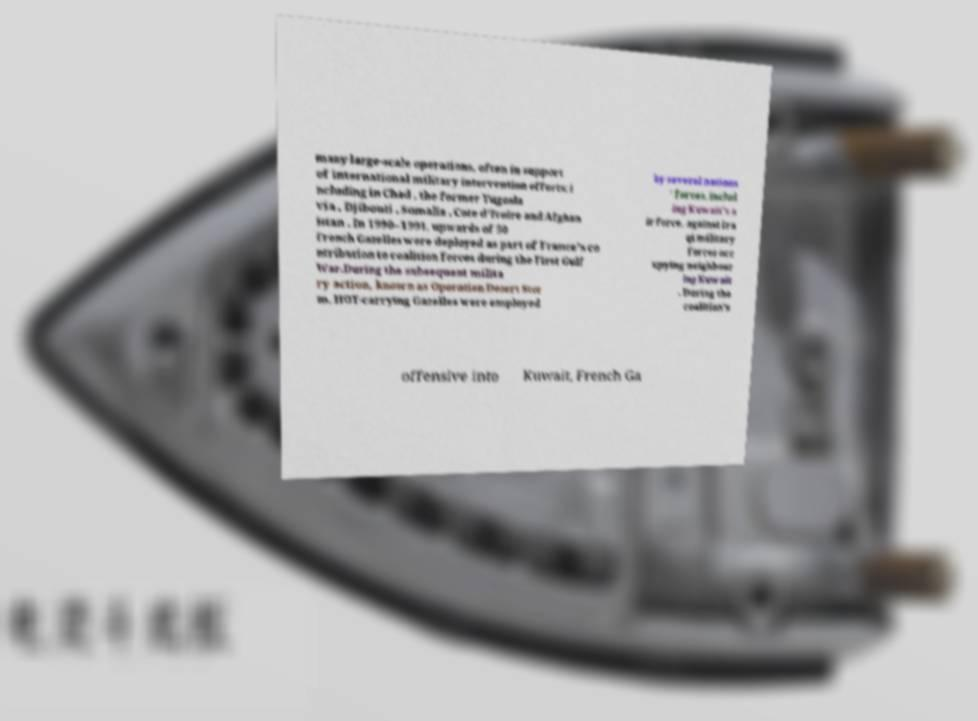For documentation purposes, I need the text within this image transcribed. Could you provide that? many large-scale operations, often in support of international military intervention efforts; i ncluding in Chad , the former Yugosla via , Djibouti , Somalia , Cote d'Ivoire and Afghan istan . In 1990–1991, upwards of 50 French Gazelles were deployed as part of France's co ntribution to coalition forces during the First Gulf War.During the subsequent milita ry action, known as Operation Desert Stor m, HOT-carrying Gazelles were employed by several nations ' forces, includ ing Kuwait's a ir force, against Ira qi military forces occ upying neighbour ing Kuwait . During the coalition's offensive into Kuwait, French Ga 